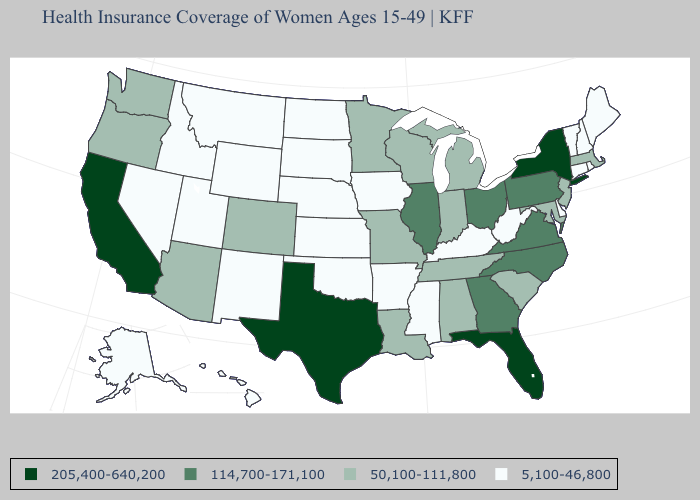Does the first symbol in the legend represent the smallest category?
Concise answer only. No. Among the states that border Washington , which have the lowest value?
Give a very brief answer. Idaho. What is the lowest value in the USA?
Concise answer only. 5,100-46,800. What is the value of Wyoming?
Give a very brief answer. 5,100-46,800. What is the lowest value in the South?
Short answer required. 5,100-46,800. Which states have the highest value in the USA?
Keep it brief. California, Florida, New York, Texas. What is the value of Florida?
Give a very brief answer. 205,400-640,200. Does Georgia have a higher value than Ohio?
Be succinct. No. What is the value of Missouri?
Write a very short answer. 50,100-111,800. Does New York have a higher value than Georgia?
Short answer required. Yes. Is the legend a continuous bar?
Answer briefly. No. Does Texas have the same value as Alaska?
Be succinct. No. Does the map have missing data?
Short answer required. No. What is the highest value in the USA?
Concise answer only. 205,400-640,200. 